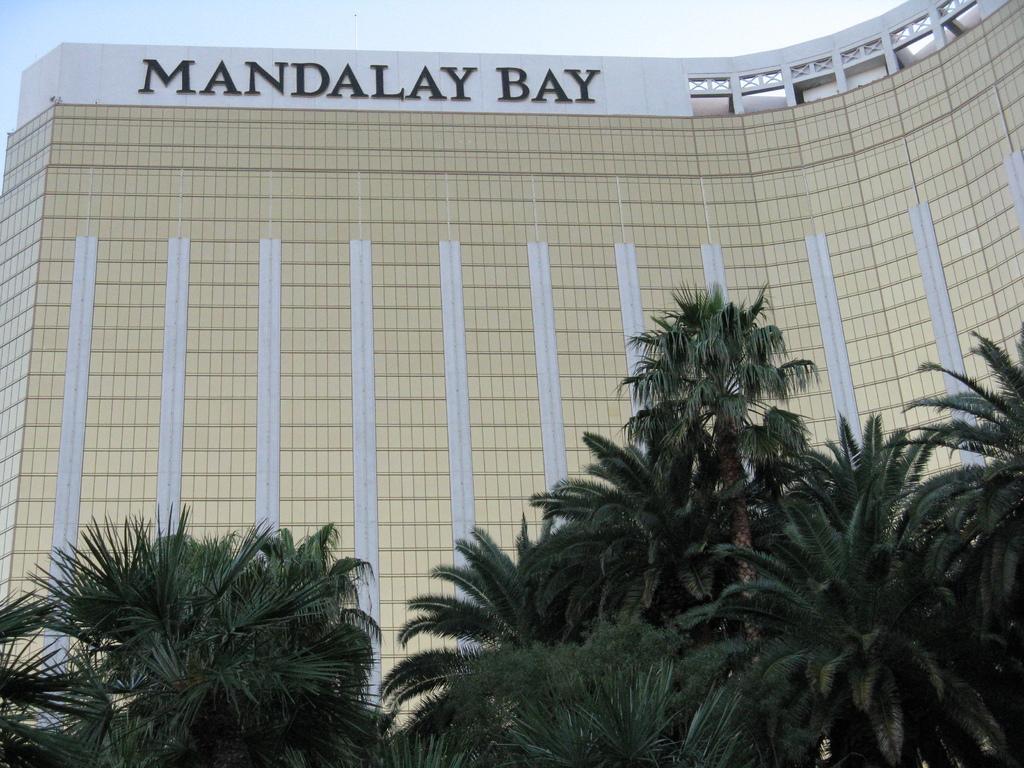Please provide a concise description of this image. In the picture we can see a huge building which is cream in color an down the top of it, we can see a name MANDALAY BAY and near to the building we can see trees and behind the building we can see a sky. 